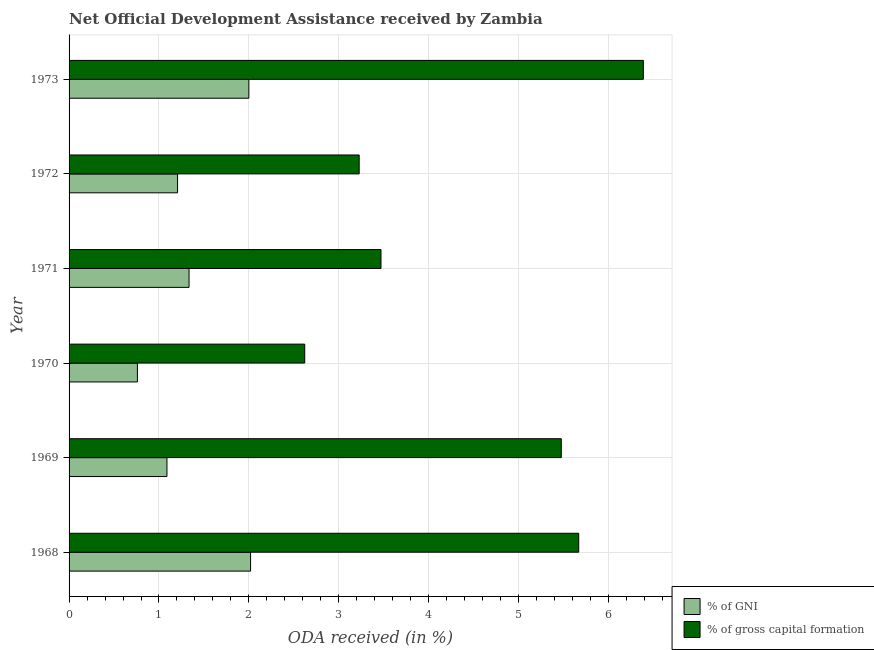How many different coloured bars are there?
Offer a terse response. 2. Are the number of bars per tick equal to the number of legend labels?
Give a very brief answer. Yes. How many bars are there on the 5th tick from the top?
Provide a short and direct response. 2. In how many cases, is the number of bars for a given year not equal to the number of legend labels?
Provide a short and direct response. 0. What is the oda received as percentage of gross capital formation in 1973?
Provide a succinct answer. 6.39. Across all years, what is the maximum oda received as percentage of gross capital formation?
Offer a very short reply. 6.39. Across all years, what is the minimum oda received as percentage of gross capital formation?
Offer a terse response. 2.62. In which year was the oda received as percentage of gni maximum?
Provide a succinct answer. 1968. What is the total oda received as percentage of gni in the graph?
Make the answer very short. 8.41. What is the difference between the oda received as percentage of gni in 1970 and that in 1971?
Keep it short and to the point. -0.57. What is the difference between the oda received as percentage of gross capital formation in 1971 and the oda received as percentage of gni in 1968?
Make the answer very short. 1.45. What is the average oda received as percentage of gni per year?
Provide a short and direct response. 1.4. In the year 1968, what is the difference between the oda received as percentage of gni and oda received as percentage of gross capital formation?
Ensure brevity in your answer.  -3.65. In how many years, is the oda received as percentage of gross capital formation greater than 1 %?
Make the answer very short. 6. What is the ratio of the oda received as percentage of gross capital formation in 1969 to that in 1971?
Provide a short and direct response. 1.58. Is the oda received as percentage of gross capital formation in 1971 less than that in 1973?
Your answer should be very brief. Yes. What is the difference between the highest and the second highest oda received as percentage of gross capital formation?
Provide a succinct answer. 0.72. What is the difference between the highest and the lowest oda received as percentage of gni?
Your response must be concise. 1.26. In how many years, is the oda received as percentage of gni greater than the average oda received as percentage of gni taken over all years?
Your answer should be very brief. 2. Is the sum of the oda received as percentage of gross capital formation in 1970 and 1973 greater than the maximum oda received as percentage of gni across all years?
Provide a short and direct response. Yes. What does the 1st bar from the top in 1971 represents?
Offer a very short reply. % of gross capital formation. What does the 1st bar from the bottom in 1969 represents?
Ensure brevity in your answer.  % of GNI. Are all the bars in the graph horizontal?
Provide a succinct answer. Yes. What is the difference between two consecutive major ticks on the X-axis?
Ensure brevity in your answer.  1. Does the graph contain any zero values?
Provide a succinct answer. No. Where does the legend appear in the graph?
Provide a succinct answer. Bottom right. How many legend labels are there?
Your response must be concise. 2. What is the title of the graph?
Offer a very short reply. Net Official Development Assistance received by Zambia. Does "Male entrants" appear as one of the legend labels in the graph?
Provide a short and direct response. No. What is the label or title of the X-axis?
Give a very brief answer. ODA received (in %). What is the ODA received (in %) of % of GNI in 1968?
Your answer should be very brief. 2.02. What is the ODA received (in %) of % of gross capital formation in 1968?
Your answer should be very brief. 5.67. What is the ODA received (in %) of % of GNI in 1969?
Provide a short and direct response. 1.09. What is the ODA received (in %) in % of gross capital formation in 1969?
Give a very brief answer. 5.47. What is the ODA received (in %) in % of GNI in 1970?
Your answer should be compact. 0.76. What is the ODA received (in %) in % of gross capital formation in 1970?
Offer a very short reply. 2.62. What is the ODA received (in %) of % of GNI in 1971?
Your answer should be very brief. 1.33. What is the ODA received (in %) in % of gross capital formation in 1971?
Keep it short and to the point. 3.47. What is the ODA received (in %) in % of GNI in 1972?
Offer a terse response. 1.21. What is the ODA received (in %) of % of gross capital formation in 1972?
Give a very brief answer. 3.23. What is the ODA received (in %) in % of GNI in 1973?
Offer a terse response. 2. What is the ODA received (in %) of % of gross capital formation in 1973?
Ensure brevity in your answer.  6.39. Across all years, what is the maximum ODA received (in %) of % of GNI?
Offer a very short reply. 2.02. Across all years, what is the maximum ODA received (in %) of % of gross capital formation?
Your answer should be very brief. 6.39. Across all years, what is the minimum ODA received (in %) in % of GNI?
Offer a terse response. 0.76. Across all years, what is the minimum ODA received (in %) of % of gross capital formation?
Provide a short and direct response. 2.62. What is the total ODA received (in %) of % of GNI in the graph?
Offer a terse response. 8.41. What is the total ODA received (in %) in % of gross capital formation in the graph?
Offer a very short reply. 26.85. What is the difference between the ODA received (in %) in % of GNI in 1968 and that in 1969?
Provide a succinct answer. 0.93. What is the difference between the ODA received (in %) of % of gross capital formation in 1968 and that in 1969?
Your answer should be compact. 0.19. What is the difference between the ODA received (in %) of % of GNI in 1968 and that in 1970?
Provide a short and direct response. 1.26. What is the difference between the ODA received (in %) of % of gross capital formation in 1968 and that in 1970?
Make the answer very short. 3.05. What is the difference between the ODA received (in %) in % of GNI in 1968 and that in 1971?
Keep it short and to the point. 0.68. What is the difference between the ODA received (in %) of % of gross capital formation in 1968 and that in 1971?
Make the answer very short. 2.2. What is the difference between the ODA received (in %) in % of GNI in 1968 and that in 1972?
Offer a terse response. 0.81. What is the difference between the ODA received (in %) of % of gross capital formation in 1968 and that in 1972?
Your response must be concise. 2.44. What is the difference between the ODA received (in %) of % of GNI in 1968 and that in 1973?
Your answer should be very brief. 0.02. What is the difference between the ODA received (in %) in % of gross capital formation in 1968 and that in 1973?
Keep it short and to the point. -0.72. What is the difference between the ODA received (in %) of % of GNI in 1969 and that in 1970?
Your answer should be compact. 0.33. What is the difference between the ODA received (in %) in % of gross capital formation in 1969 and that in 1970?
Your answer should be compact. 2.85. What is the difference between the ODA received (in %) of % of GNI in 1969 and that in 1971?
Offer a very short reply. -0.25. What is the difference between the ODA received (in %) of % of gross capital formation in 1969 and that in 1971?
Your answer should be compact. 2.01. What is the difference between the ODA received (in %) in % of GNI in 1969 and that in 1972?
Make the answer very short. -0.12. What is the difference between the ODA received (in %) in % of gross capital formation in 1969 and that in 1972?
Make the answer very short. 2.25. What is the difference between the ODA received (in %) of % of GNI in 1969 and that in 1973?
Make the answer very short. -0.91. What is the difference between the ODA received (in %) in % of gross capital formation in 1969 and that in 1973?
Make the answer very short. -0.91. What is the difference between the ODA received (in %) in % of GNI in 1970 and that in 1971?
Make the answer very short. -0.57. What is the difference between the ODA received (in %) in % of gross capital formation in 1970 and that in 1971?
Keep it short and to the point. -0.85. What is the difference between the ODA received (in %) of % of GNI in 1970 and that in 1972?
Your answer should be very brief. -0.45. What is the difference between the ODA received (in %) of % of gross capital formation in 1970 and that in 1972?
Give a very brief answer. -0.61. What is the difference between the ODA received (in %) in % of GNI in 1970 and that in 1973?
Provide a short and direct response. -1.24. What is the difference between the ODA received (in %) in % of gross capital formation in 1970 and that in 1973?
Provide a short and direct response. -3.77. What is the difference between the ODA received (in %) in % of GNI in 1971 and that in 1972?
Offer a terse response. 0.13. What is the difference between the ODA received (in %) in % of gross capital formation in 1971 and that in 1972?
Make the answer very short. 0.24. What is the difference between the ODA received (in %) of % of GNI in 1971 and that in 1973?
Your response must be concise. -0.67. What is the difference between the ODA received (in %) in % of gross capital formation in 1971 and that in 1973?
Provide a short and direct response. -2.92. What is the difference between the ODA received (in %) in % of GNI in 1972 and that in 1973?
Provide a succinct answer. -0.79. What is the difference between the ODA received (in %) of % of gross capital formation in 1972 and that in 1973?
Give a very brief answer. -3.16. What is the difference between the ODA received (in %) in % of GNI in 1968 and the ODA received (in %) in % of gross capital formation in 1969?
Keep it short and to the point. -3.46. What is the difference between the ODA received (in %) of % of GNI in 1968 and the ODA received (in %) of % of gross capital formation in 1970?
Ensure brevity in your answer.  -0.6. What is the difference between the ODA received (in %) in % of GNI in 1968 and the ODA received (in %) in % of gross capital formation in 1971?
Give a very brief answer. -1.45. What is the difference between the ODA received (in %) in % of GNI in 1968 and the ODA received (in %) in % of gross capital formation in 1972?
Ensure brevity in your answer.  -1.21. What is the difference between the ODA received (in %) of % of GNI in 1968 and the ODA received (in %) of % of gross capital formation in 1973?
Your answer should be compact. -4.37. What is the difference between the ODA received (in %) in % of GNI in 1969 and the ODA received (in %) in % of gross capital formation in 1970?
Keep it short and to the point. -1.53. What is the difference between the ODA received (in %) of % of GNI in 1969 and the ODA received (in %) of % of gross capital formation in 1971?
Give a very brief answer. -2.38. What is the difference between the ODA received (in %) of % of GNI in 1969 and the ODA received (in %) of % of gross capital formation in 1972?
Offer a terse response. -2.14. What is the difference between the ODA received (in %) of % of GNI in 1969 and the ODA received (in %) of % of gross capital formation in 1973?
Your answer should be compact. -5.3. What is the difference between the ODA received (in %) in % of GNI in 1970 and the ODA received (in %) in % of gross capital formation in 1971?
Your response must be concise. -2.71. What is the difference between the ODA received (in %) of % of GNI in 1970 and the ODA received (in %) of % of gross capital formation in 1972?
Provide a short and direct response. -2.47. What is the difference between the ODA received (in %) in % of GNI in 1970 and the ODA received (in %) in % of gross capital formation in 1973?
Your answer should be very brief. -5.63. What is the difference between the ODA received (in %) of % of GNI in 1971 and the ODA received (in %) of % of gross capital formation in 1972?
Provide a short and direct response. -1.89. What is the difference between the ODA received (in %) of % of GNI in 1971 and the ODA received (in %) of % of gross capital formation in 1973?
Ensure brevity in your answer.  -5.05. What is the difference between the ODA received (in %) of % of GNI in 1972 and the ODA received (in %) of % of gross capital formation in 1973?
Your answer should be compact. -5.18. What is the average ODA received (in %) in % of GNI per year?
Your answer should be compact. 1.4. What is the average ODA received (in %) in % of gross capital formation per year?
Offer a terse response. 4.47. In the year 1968, what is the difference between the ODA received (in %) in % of GNI and ODA received (in %) in % of gross capital formation?
Provide a short and direct response. -3.65. In the year 1969, what is the difference between the ODA received (in %) in % of GNI and ODA received (in %) in % of gross capital formation?
Your response must be concise. -4.39. In the year 1970, what is the difference between the ODA received (in %) of % of GNI and ODA received (in %) of % of gross capital formation?
Your answer should be compact. -1.86. In the year 1971, what is the difference between the ODA received (in %) of % of GNI and ODA received (in %) of % of gross capital formation?
Offer a very short reply. -2.13. In the year 1972, what is the difference between the ODA received (in %) of % of GNI and ODA received (in %) of % of gross capital formation?
Your answer should be very brief. -2.02. In the year 1973, what is the difference between the ODA received (in %) in % of GNI and ODA received (in %) in % of gross capital formation?
Provide a succinct answer. -4.39. What is the ratio of the ODA received (in %) of % of GNI in 1968 to that in 1969?
Your answer should be compact. 1.85. What is the ratio of the ODA received (in %) in % of gross capital formation in 1968 to that in 1969?
Offer a terse response. 1.04. What is the ratio of the ODA received (in %) of % of GNI in 1968 to that in 1970?
Make the answer very short. 2.66. What is the ratio of the ODA received (in %) in % of gross capital formation in 1968 to that in 1970?
Make the answer very short. 2.16. What is the ratio of the ODA received (in %) of % of GNI in 1968 to that in 1971?
Make the answer very short. 1.51. What is the ratio of the ODA received (in %) of % of gross capital formation in 1968 to that in 1971?
Provide a short and direct response. 1.63. What is the ratio of the ODA received (in %) of % of GNI in 1968 to that in 1972?
Your answer should be very brief. 1.67. What is the ratio of the ODA received (in %) in % of gross capital formation in 1968 to that in 1972?
Your response must be concise. 1.76. What is the ratio of the ODA received (in %) of % of GNI in 1968 to that in 1973?
Your answer should be very brief. 1.01. What is the ratio of the ODA received (in %) of % of gross capital formation in 1968 to that in 1973?
Give a very brief answer. 0.89. What is the ratio of the ODA received (in %) in % of GNI in 1969 to that in 1970?
Give a very brief answer. 1.43. What is the ratio of the ODA received (in %) of % of gross capital formation in 1969 to that in 1970?
Your answer should be compact. 2.09. What is the ratio of the ODA received (in %) of % of GNI in 1969 to that in 1971?
Give a very brief answer. 0.82. What is the ratio of the ODA received (in %) in % of gross capital formation in 1969 to that in 1971?
Your response must be concise. 1.58. What is the ratio of the ODA received (in %) in % of GNI in 1969 to that in 1972?
Keep it short and to the point. 0.9. What is the ratio of the ODA received (in %) in % of gross capital formation in 1969 to that in 1972?
Provide a short and direct response. 1.7. What is the ratio of the ODA received (in %) of % of GNI in 1969 to that in 1973?
Provide a short and direct response. 0.54. What is the ratio of the ODA received (in %) of % of gross capital formation in 1969 to that in 1973?
Make the answer very short. 0.86. What is the ratio of the ODA received (in %) of % of GNI in 1970 to that in 1971?
Keep it short and to the point. 0.57. What is the ratio of the ODA received (in %) in % of gross capital formation in 1970 to that in 1971?
Offer a very short reply. 0.76. What is the ratio of the ODA received (in %) in % of GNI in 1970 to that in 1972?
Provide a short and direct response. 0.63. What is the ratio of the ODA received (in %) in % of gross capital formation in 1970 to that in 1972?
Make the answer very short. 0.81. What is the ratio of the ODA received (in %) in % of GNI in 1970 to that in 1973?
Your response must be concise. 0.38. What is the ratio of the ODA received (in %) of % of gross capital formation in 1970 to that in 1973?
Offer a terse response. 0.41. What is the ratio of the ODA received (in %) of % of GNI in 1971 to that in 1972?
Offer a terse response. 1.11. What is the ratio of the ODA received (in %) of % of gross capital formation in 1971 to that in 1972?
Your response must be concise. 1.08. What is the ratio of the ODA received (in %) of % of GNI in 1971 to that in 1973?
Provide a short and direct response. 0.67. What is the ratio of the ODA received (in %) in % of gross capital formation in 1971 to that in 1973?
Give a very brief answer. 0.54. What is the ratio of the ODA received (in %) of % of GNI in 1972 to that in 1973?
Your answer should be very brief. 0.6. What is the ratio of the ODA received (in %) in % of gross capital formation in 1972 to that in 1973?
Your answer should be compact. 0.51. What is the difference between the highest and the second highest ODA received (in %) of % of GNI?
Ensure brevity in your answer.  0.02. What is the difference between the highest and the second highest ODA received (in %) of % of gross capital formation?
Keep it short and to the point. 0.72. What is the difference between the highest and the lowest ODA received (in %) of % of GNI?
Provide a short and direct response. 1.26. What is the difference between the highest and the lowest ODA received (in %) of % of gross capital formation?
Make the answer very short. 3.77. 